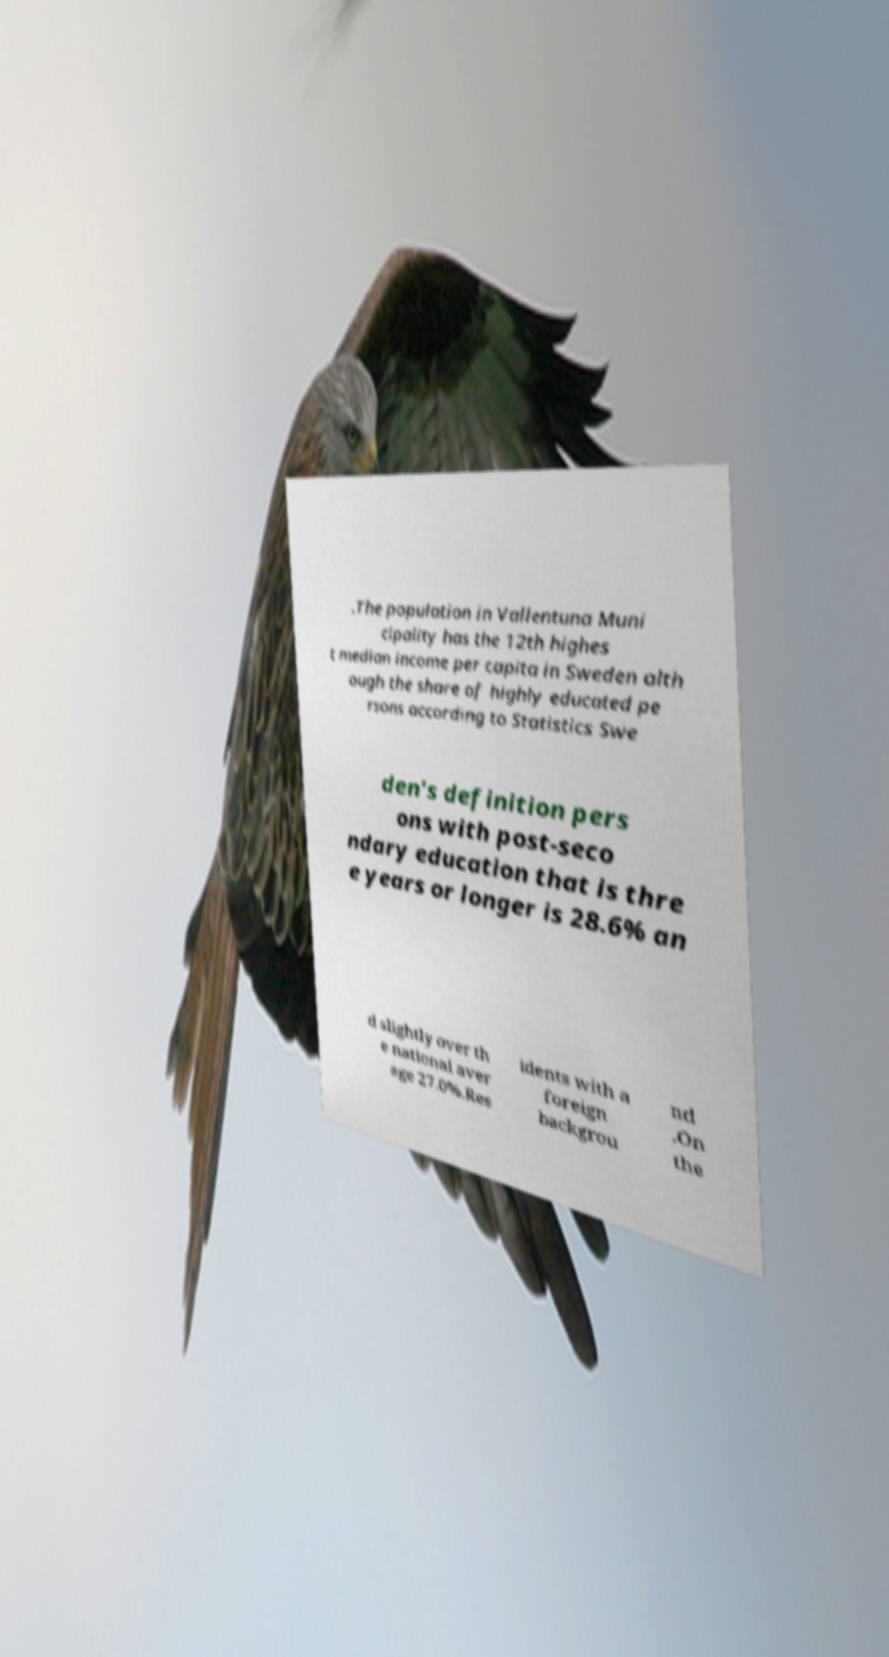Can you read and provide the text displayed in the image?This photo seems to have some interesting text. Can you extract and type it out for me? .The population in Vallentuna Muni cipality has the 12th highes t median income per capita in Sweden alth ough the share of highly educated pe rsons according to Statistics Swe den's definition pers ons with post-seco ndary education that is thre e years or longer is 28.6% an d slightly over th e national aver age 27.0%.Res idents with a foreign backgrou nd .On the 